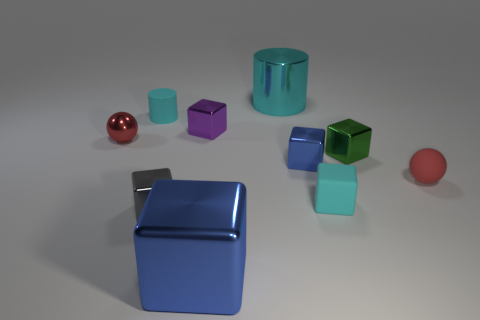Is the shape of the purple object the same as the large cyan thing? no 